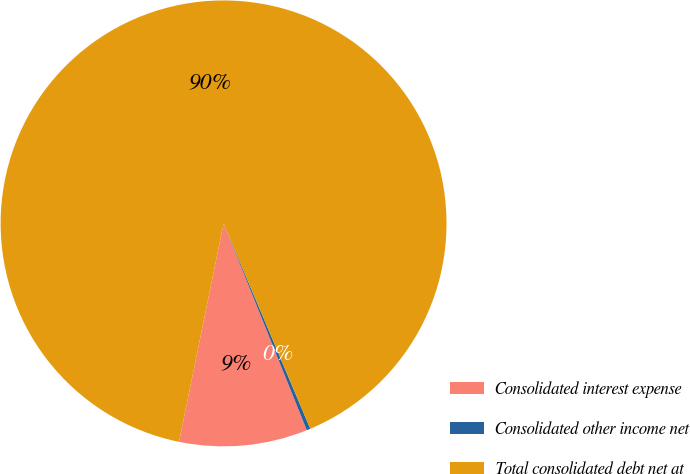<chart> <loc_0><loc_0><loc_500><loc_500><pie_chart><fcel>Consolidated interest expense<fcel>Consolidated other income net<fcel>Total consolidated debt net at<nl><fcel>9.29%<fcel>0.27%<fcel>90.44%<nl></chart> 